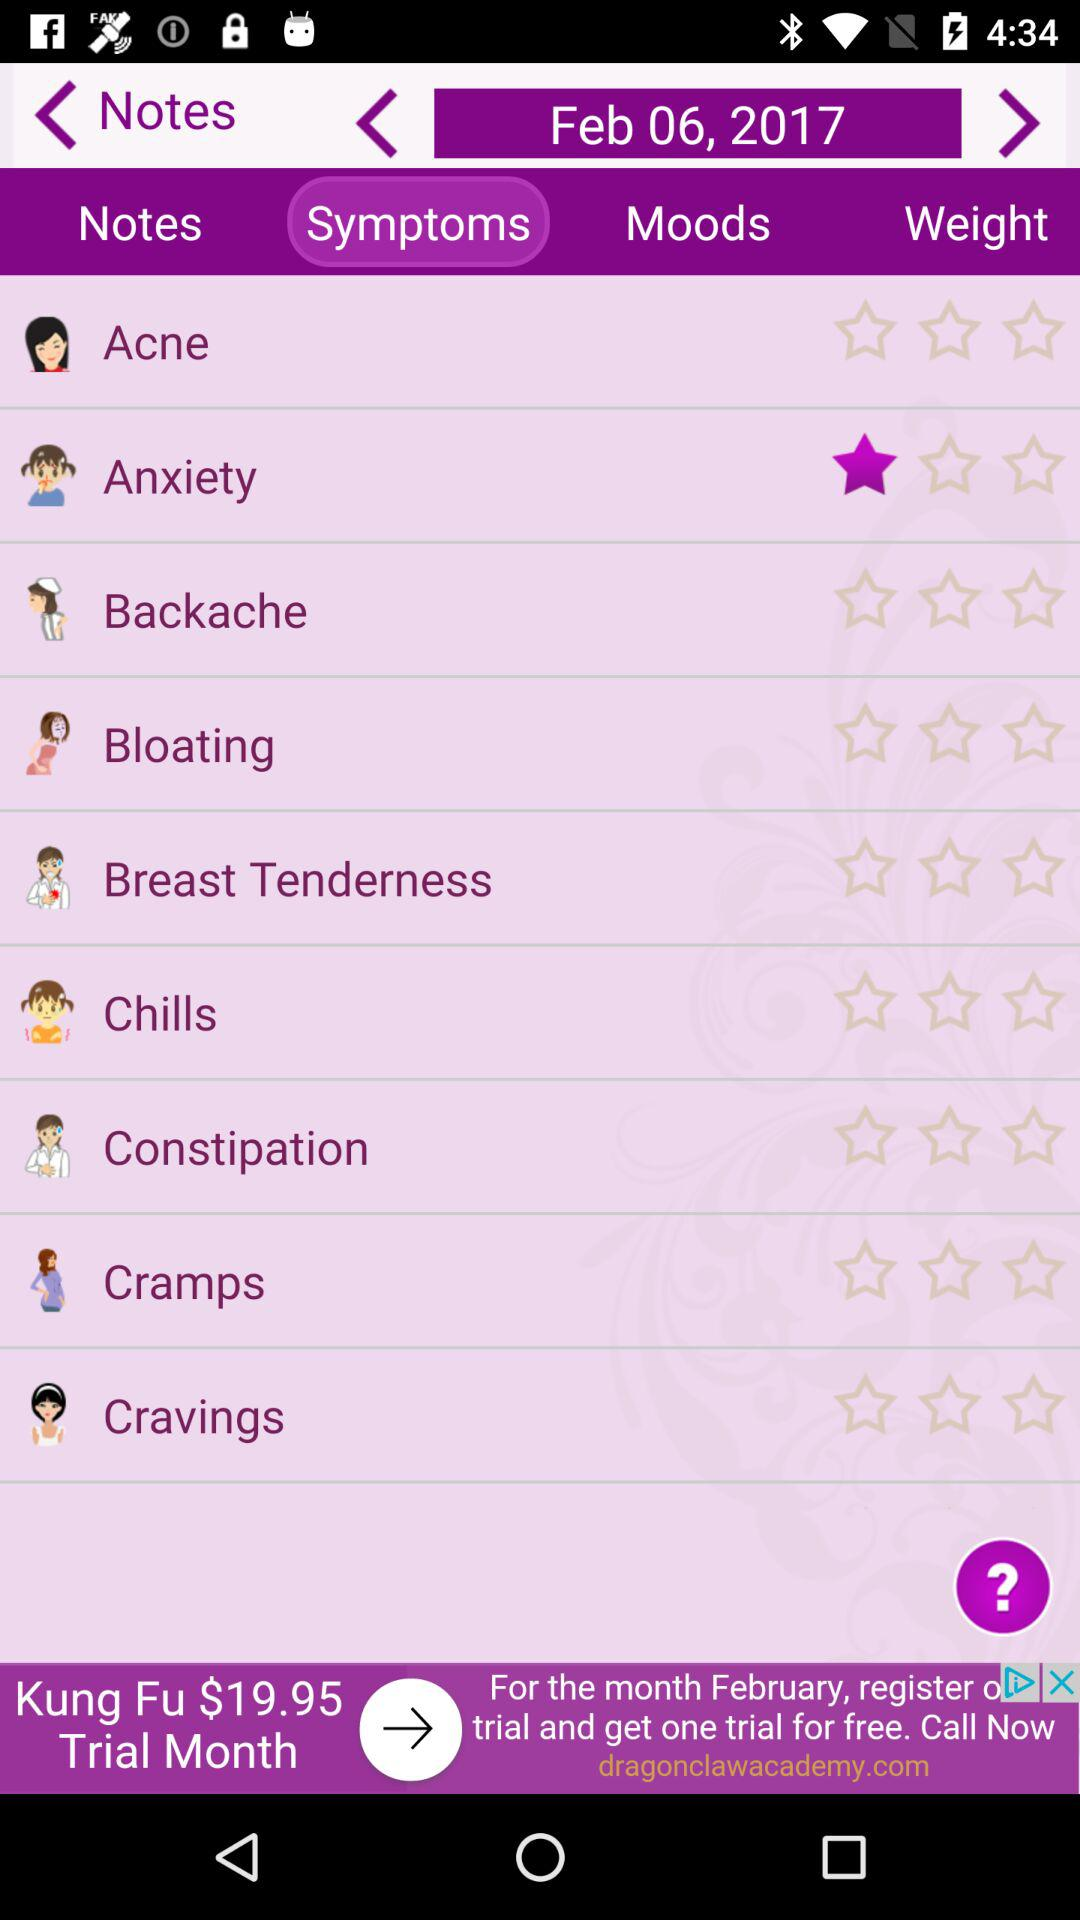What is the rating of "Anxiety"? The rating of "Anxiety" is 1 star. 